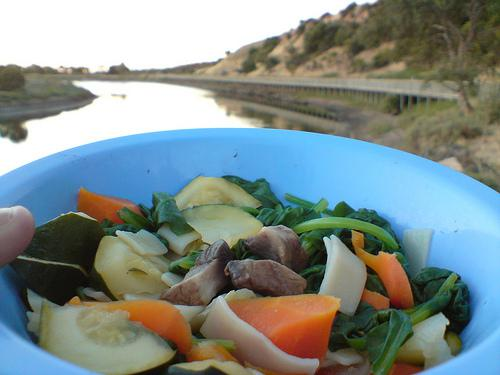Question: when is the salad being eaten?
Choices:
A. Right now.
B. Yesterday.
C. During the day.
D. Previously.
Answer with the letter. Answer: C Question: who is on the river?
Choices:
A. A fisherman.
B. No one.
C. A woman.
D. Two men on the kayak.
Answer with the letter. Answer: B Question: how is the current?
Choices:
A. Rough.
B. Calm.
C. Dangerous.
D. Strong.
Answer with the letter. Answer: B Question: what can you see on the left?
Choices:
A. A finger.
B. An open palm.
C. A fragment of a man's arm.
D. A foot.
Answer with the letter. Answer: A 